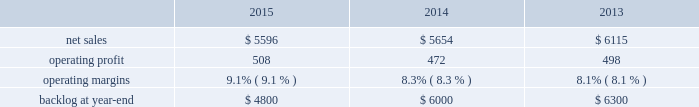Backlog backlog increased in 2015 compared to 2014 primarily due to higher orders on f-35 and c-130 programs .
Backlog decreased slightly in 2014 compared to 2013 primarily due to lower orders on f-16 and f-22 programs .
Trends we expect aeronautics 2019 2016 net sales to increase in the mid-single digit percentage range as compared to 2015 due to increased volume on the f-35 and c-130 programs , partially offset by decreased volume on the f-16 program .
Operating profit is also expected to increase in the low single-digit percentage range , driven by increased volume on the f-35 program offset by contract mix that results in a slight decrease in operating margins between years .
Information systems & global solutions our is&gs business segment provides advanced technology systems and expertise , integrated information technology solutions and management services across a broad spectrum of applications for civil , defense , intelligence and other government customers .
Is&gs 2019 technical services business provides a comprehensive portfolio of technical and sustainment services .
Is&gs has a portfolio of many smaller contracts as compared to our other business segments .
Is&gs has been impacted by the continued downturn in certain federal agencies 2019 information technology budgets and increased re-competition on existing contracts coupled with the fragmentation of large contracts into multiple smaller contracts that are awarded primarily on the basis of price .
Is&gs 2019 operating results included the following ( in millions ) : .
2015 compared to 2014 is&gs 2019 net sales decreased $ 58 million , or 1% ( 1 % ) , in 2015 as compared to 2014 .
The decrease was attributable to lower net sales of approximately $ 395 million as a result of key program completions , lower customer funding levels and increased competition , coupled with the fragmentation of existing large contracts into multiple smaller contracts that are awarded primarily on the basis of price when re-competed ( including cms-citic ) .
These decreases were partially offset by higher net sales of approximately $ 230 million for businesses acquired in 2014 ; and approximately $ 110 million due to the start-up of new programs and growth in recently awarded programs .
Is&gs 2019 operating profit increased $ 36 million , or 8% ( 8 % ) , in 2015 as compared to 2014 .
The increase was attributable to improved program performance and risk retirements , offset by decreased operating profit resulting from the activities mentioned above for net sales .
Adjustments not related to volume , including net profit booking rate adjustments and other matters , were approximately $ 70 million higher in 2015 compared to 2014 .
2014 compared to 2013 is&gs 2019 net sales decreased $ 461 million , or 8% ( 8 % ) , in 2014 as compared to 2013 .
The decrease was primarily attributable to lower net sales of about $ 475 million due to the wind-down or completion of certain programs , driven by reductions in direct warfighter support ( including jieddo ) ; and approximately $ 320 million due to decreased volume in technical services programs reflecting market pressures .
The decreases were offset by higher net sales of about $ 330 million due to the start-up of new programs , growth in recently awarded programs and integration of recently acquired companies .
Is&gs 2019 operating profit decreased $ 26 million , or 5% ( 5 % ) , in 2014 as compared to 2013 .
The decrease was primarily attributable to the activities mentioned above for sales , partially offset by severance recoveries related to the restructuring announced in november 2013 of approximately $ 20 million in 2014 .
Adjustments not related to volume , including net profit booking rate adjustments , were comparable in 2014 and 2013. .
What was the average backlog at year-end from 2013 to 2015? 
Computations: (((4800 + 6000) + 6300) / 3)
Answer: 5700.0. 